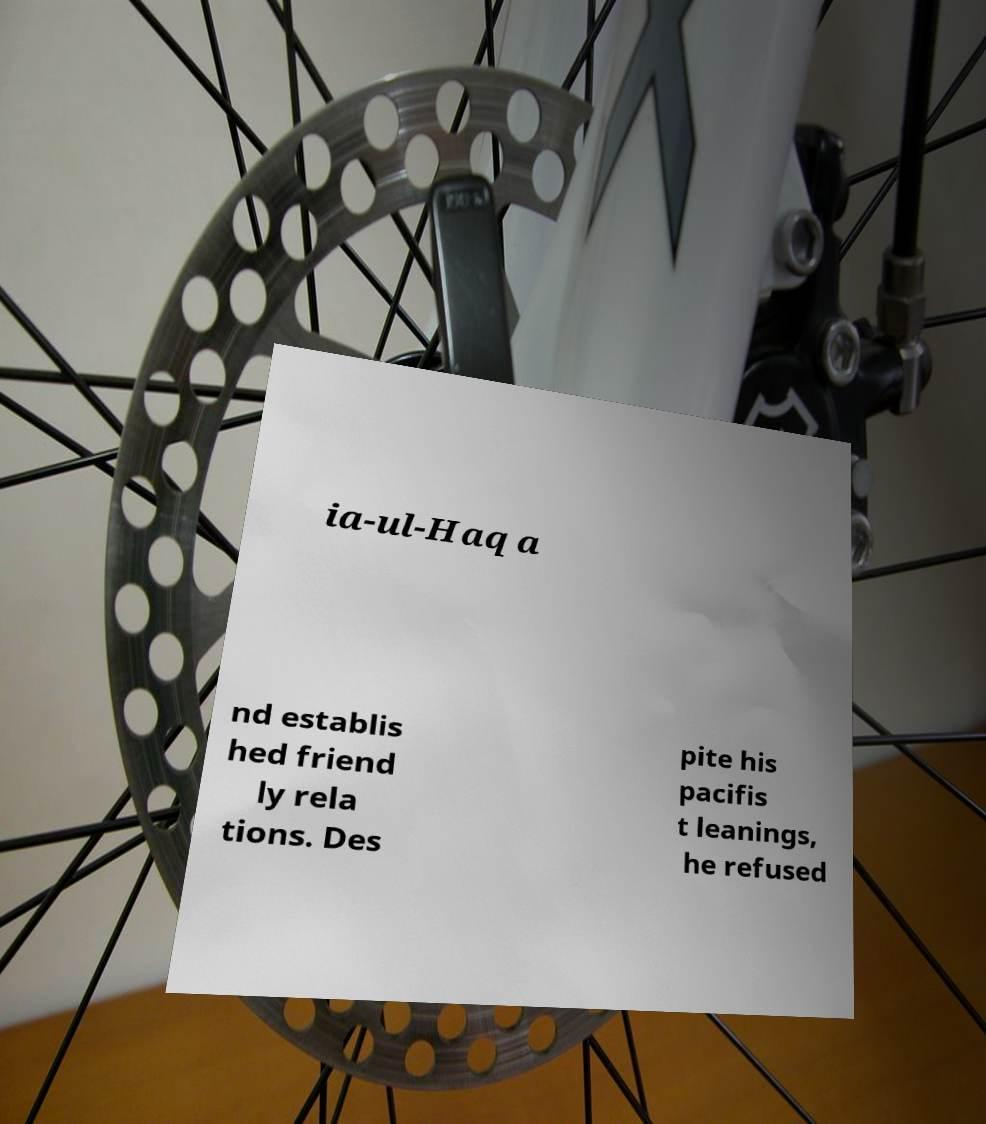Please identify and transcribe the text found in this image. ia-ul-Haq a nd establis hed friend ly rela tions. Des pite his pacifis t leanings, he refused 